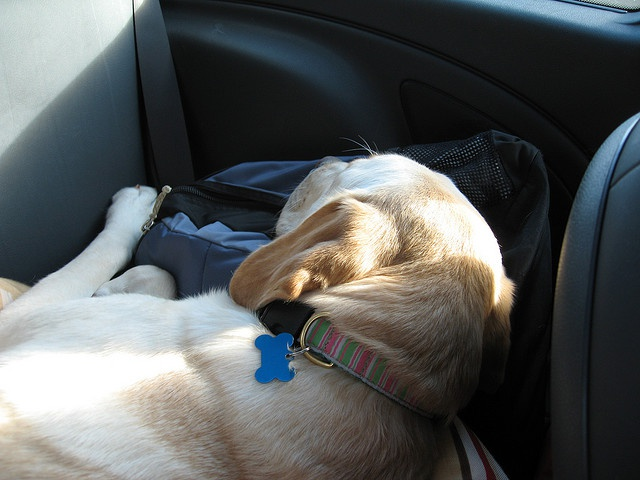Describe the objects in this image and their specific colors. I can see dog in lightgray, white, gray, darkgray, and black tones and backpack in lightgray, black, navy, blue, and gray tones in this image. 